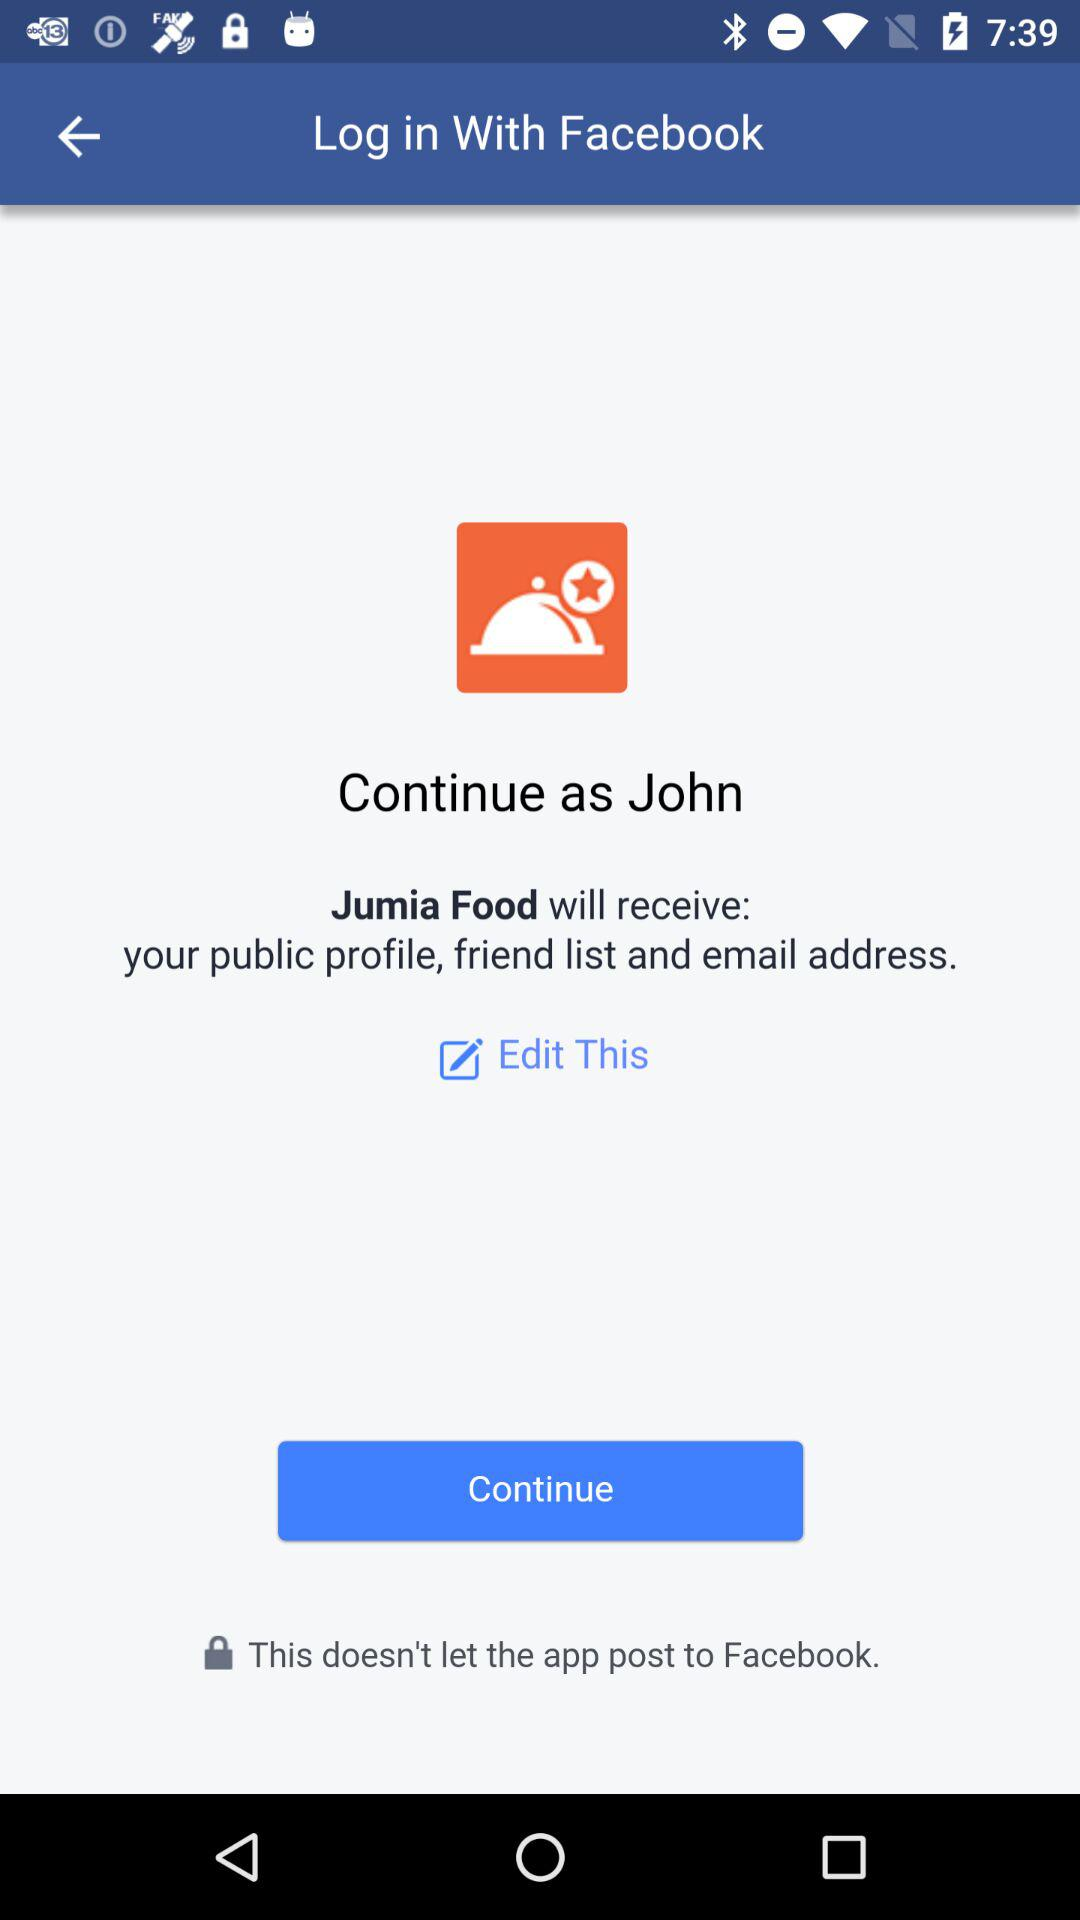What is the name of the user? The name of the user is John. 